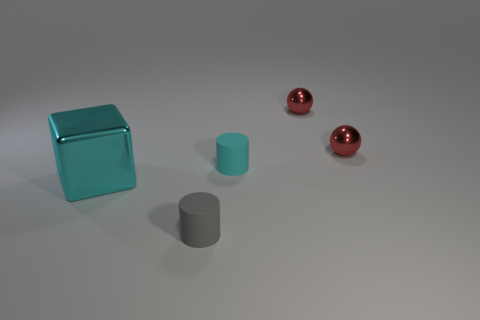How big is the matte cylinder in front of the tiny matte cylinder behind the object that is in front of the big metallic block?
Your answer should be compact. Small. Is the number of tiny cylinders less than the number of small objects?
Keep it short and to the point. Yes. What color is the other thing that is the same shape as the gray thing?
Offer a terse response. Cyan. There is a rubber object on the left side of the small matte object behind the gray rubber object; is there a tiny cyan thing that is in front of it?
Your answer should be very brief. No. Do the gray rubber object and the cyan matte object have the same shape?
Offer a very short reply. Yes. Are there fewer small gray rubber things right of the gray rubber thing than large gray balls?
Provide a succinct answer. No. There is a matte cylinder on the right side of the small cylinder in front of the big metal cube that is left of the tiny gray matte cylinder; what is its color?
Provide a succinct answer. Cyan. How many shiny things are cubes or cylinders?
Give a very brief answer. 1. Is the size of the cyan cylinder the same as the gray cylinder?
Give a very brief answer. Yes. Are there fewer cylinders that are in front of the big block than small red things that are in front of the small gray cylinder?
Give a very brief answer. No. 